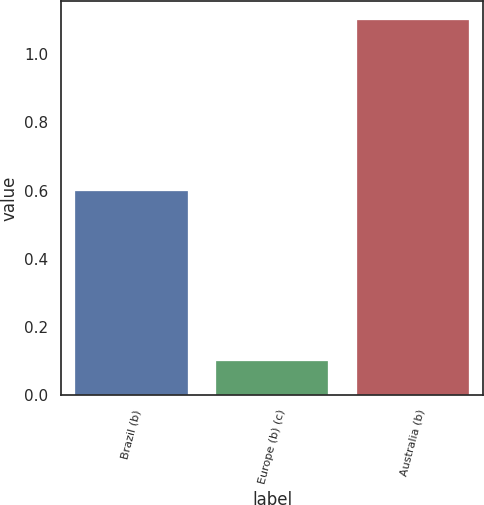<chart> <loc_0><loc_0><loc_500><loc_500><bar_chart><fcel>Brazil (b)<fcel>Europe (b) (c)<fcel>Australia (b)<nl><fcel>0.6<fcel>0.1<fcel>1.1<nl></chart> 